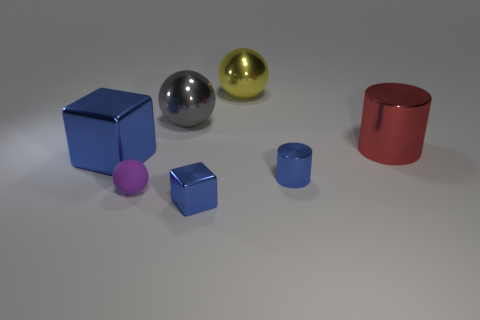Subtract all large spheres. How many spheres are left? 1 Add 3 purple spheres. How many objects exist? 10 Subtract all balls. How many objects are left? 4 Subtract all tiny cyan matte objects. Subtract all small metallic things. How many objects are left? 5 Add 6 gray spheres. How many gray spheres are left? 7 Add 5 small purple objects. How many small purple objects exist? 6 Subtract 0 brown cubes. How many objects are left? 7 